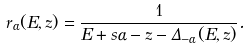<formula> <loc_0><loc_0><loc_500><loc_500>r _ { \alpha } ( E , z ) = \frac { 1 } { E + s \alpha - z - \Delta _ { - \alpha } ( E , z ) } .</formula> 